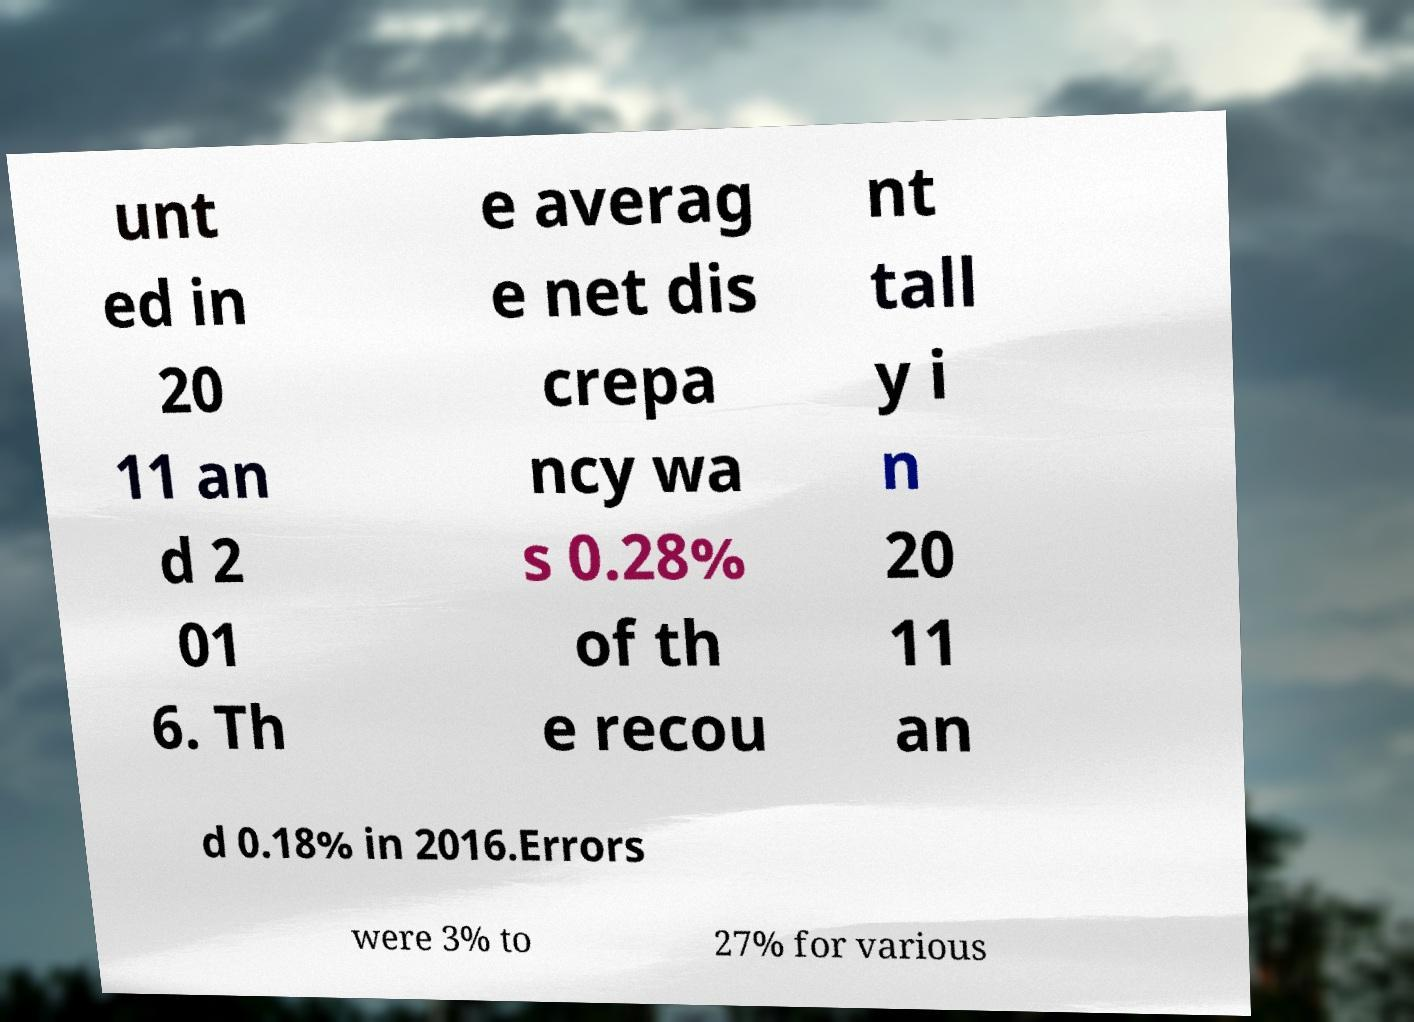For documentation purposes, I need the text within this image transcribed. Could you provide that? unt ed in 20 11 an d 2 01 6. Th e averag e net dis crepa ncy wa s 0.28% of th e recou nt tall y i n 20 11 an d 0.18% in 2016.Errors were 3% to 27% for various 